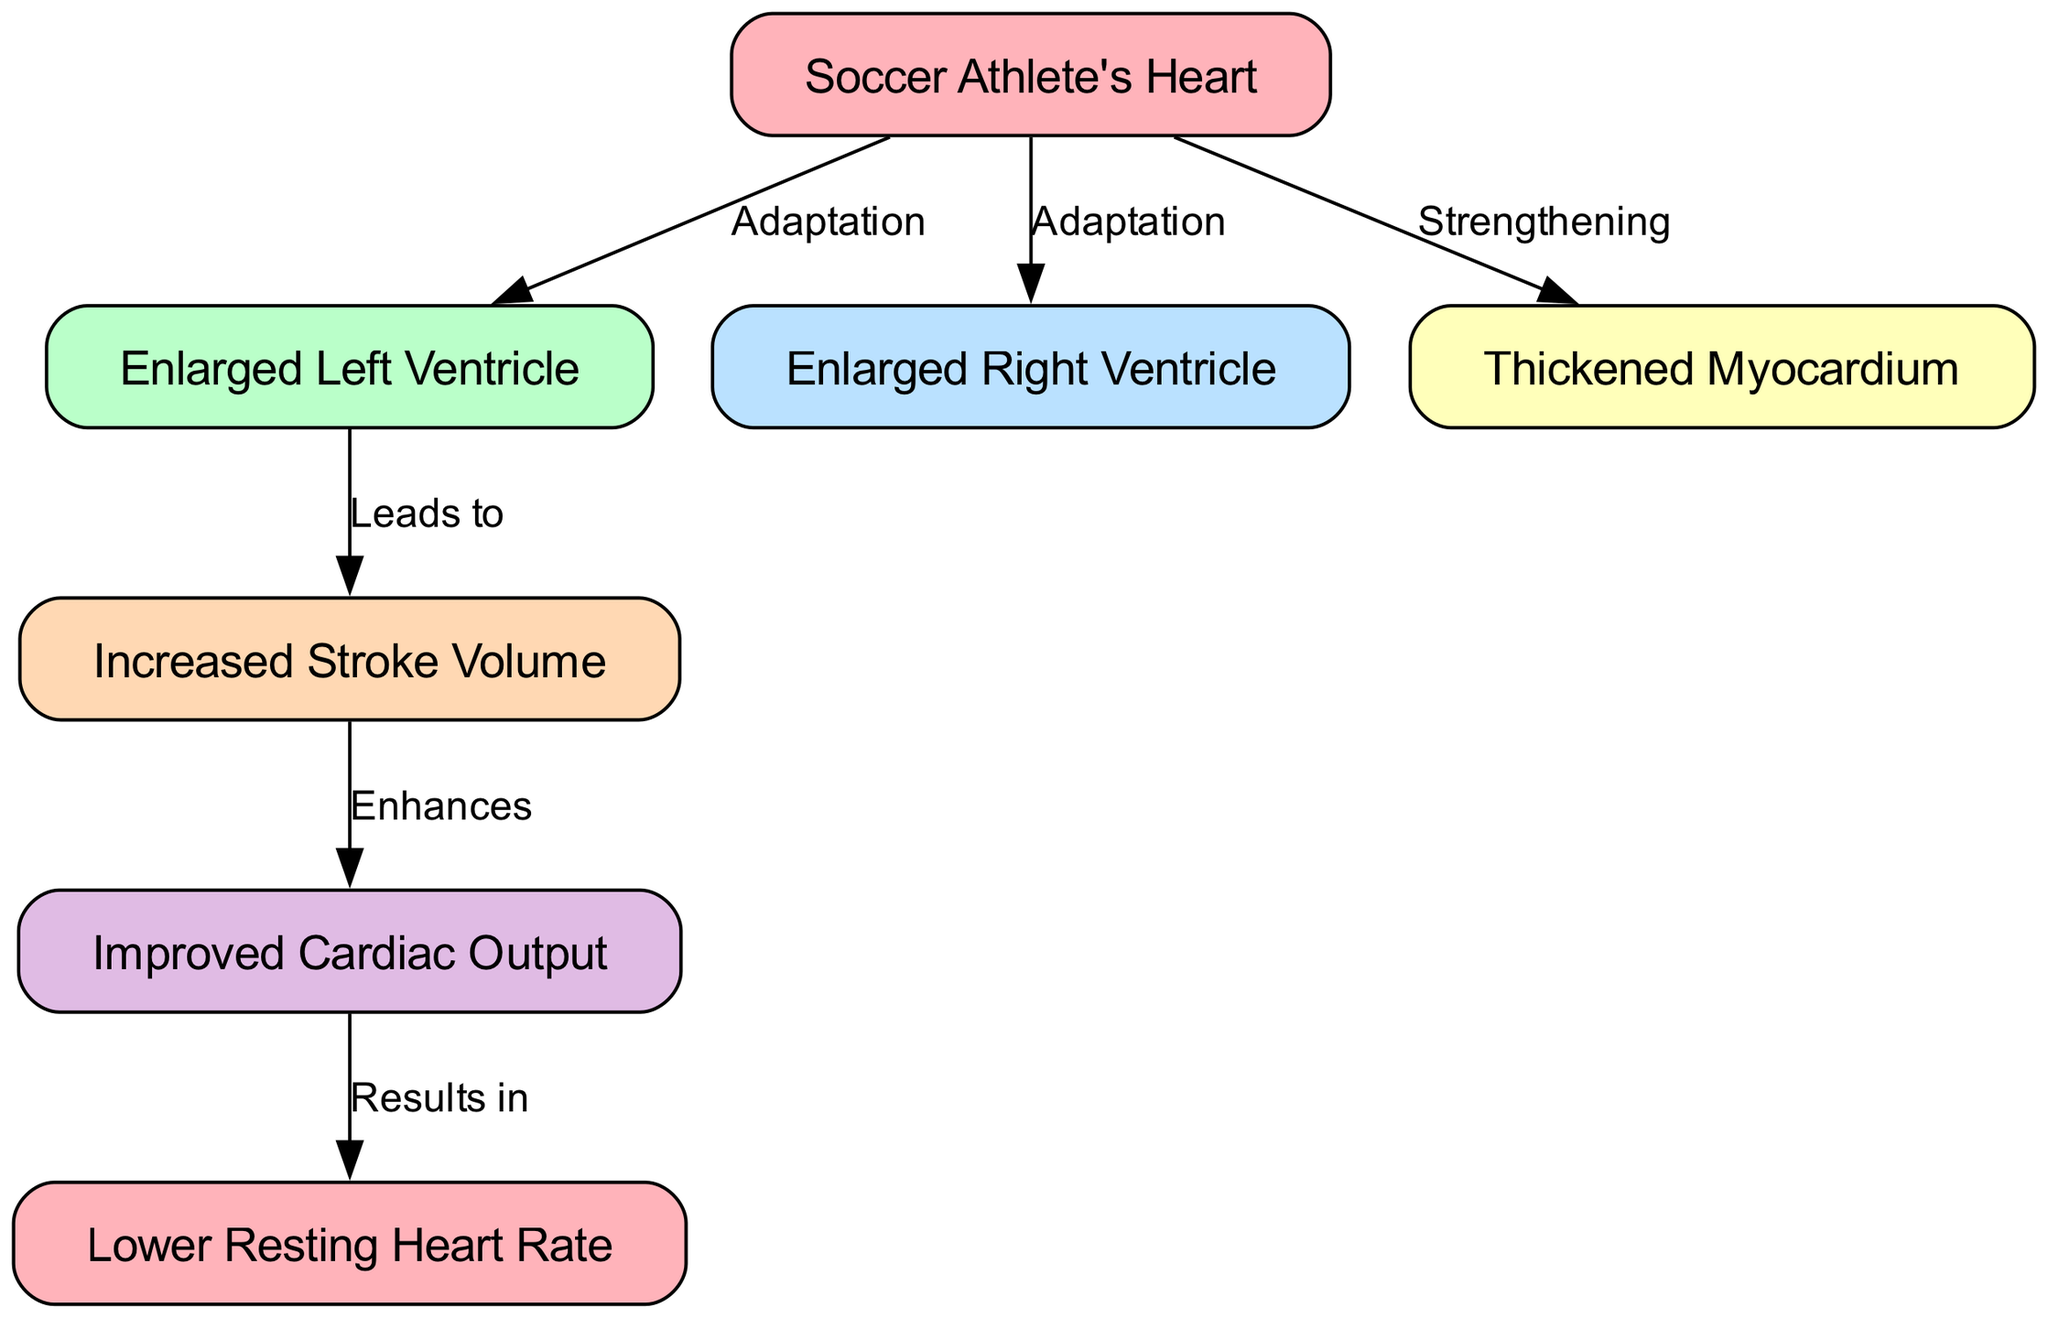What is the first adaptation represented in the diagram? The diagram shows "Enlarged Left Ventricle" as one of the adaptations stemming from the "Soccer Athlete's Heart." The flow indicates that both the left and right ventricle enlargements occur as adaptations to long-term training.
Answer: Enlarged Left Ventricle How many nodes are present in the diagram? By counting the unique nodes listed, there are a total of 7 nodes: Soccer Athlete's Heart, Enlarged Left Ventricle, Enlarged Right Ventricle, Thickened Myocardium, Increased Stroke Volume, Improved Cardiac Output, and Lower Resting Heart Rate.
Answer: 7 What does the "Thickened Myocardium" lead to? The thickening of the myocardium is described as a "Strengthening" effect related to the "Soccer Athlete's Heart," but does not lead directly to another node. Instead, it is an adaptation that supports other improvements.
Answer: Does not lead to another node What is the relationship between "Increased Stroke Volume" and "Improved Cardiac Output"? The diagram specifies that "Increased Stroke Volume" enhances "Improved Cardiac Output," showing a direct relationship where one improves the other.
Answer: Enhances What is the final result of "Improved Cardiac Output"? The last edge in the diagram indicates that the "Improved Cardiac Output" results in a "Lower Resting Heart Rate," thus this is the final outcome in the progression shown.
Answer: Lower Resting Heart Rate What adaptations are shown from the "Soccer Athlete's Heart"? The diagram indicates two adaptations stemming from the "Soccer Athlete's Heart": "Enlarged Left Ventricle" and "Enlarged Right Ventricle."
Answer: Enlarged Left Ventricle, Enlarged Right Ventricle Which edge indicates an enhancement of cardiac function? The edge from "Increased Stroke Volume" to "Improved Cardiac Output" is marked as "Enhances," indicating how stroke volume improvements contribute to better cardiac output.
Answer: Enhances What is the significance of a lower resting heart rate? While the diagram suggests that a lower resting heart rate is a result of various cardiovascular changes, specifically driven by improved heart output, it implies increased efficiency in heart function for the athlete.
Answer: Improved heart efficiency 